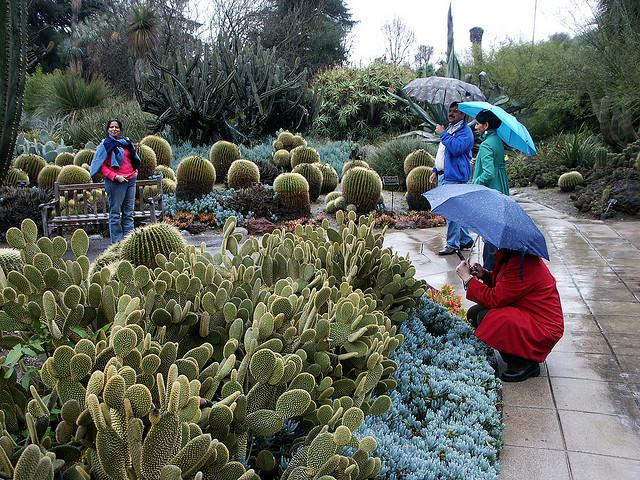What do these plants need very little of?

Choices:
A) sun
B) love
C) water
D) heat water 